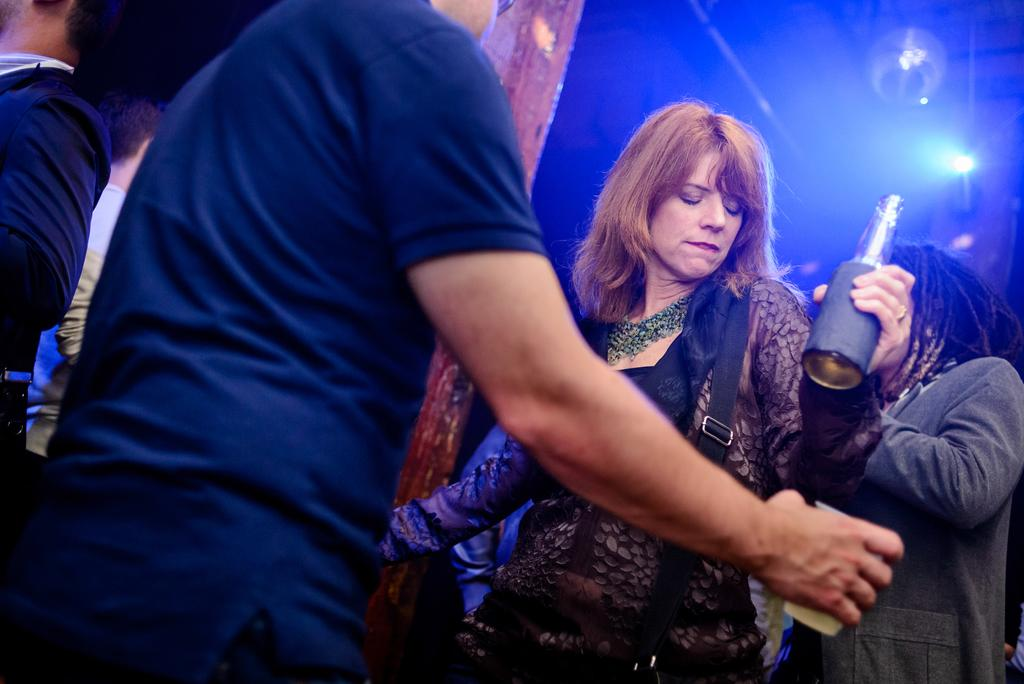What are the people in the image doing? The people in the image are holding an object. What can be seen in the background of the image? There are lights visible in the background of the image. Where is the hydrant located in the image? There is no hydrant present in the image. What type of reward is being given to the people in the image? There is no reward being given in the image; the people are simply holding an object. 